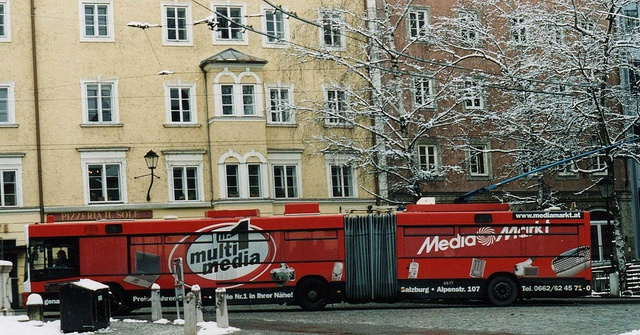Describe the objects in this image and their specific colors. I can see bus in lightgray, black, maroon, and darkgray tones and people in black, darkgreen, and lightgray tones in this image. 